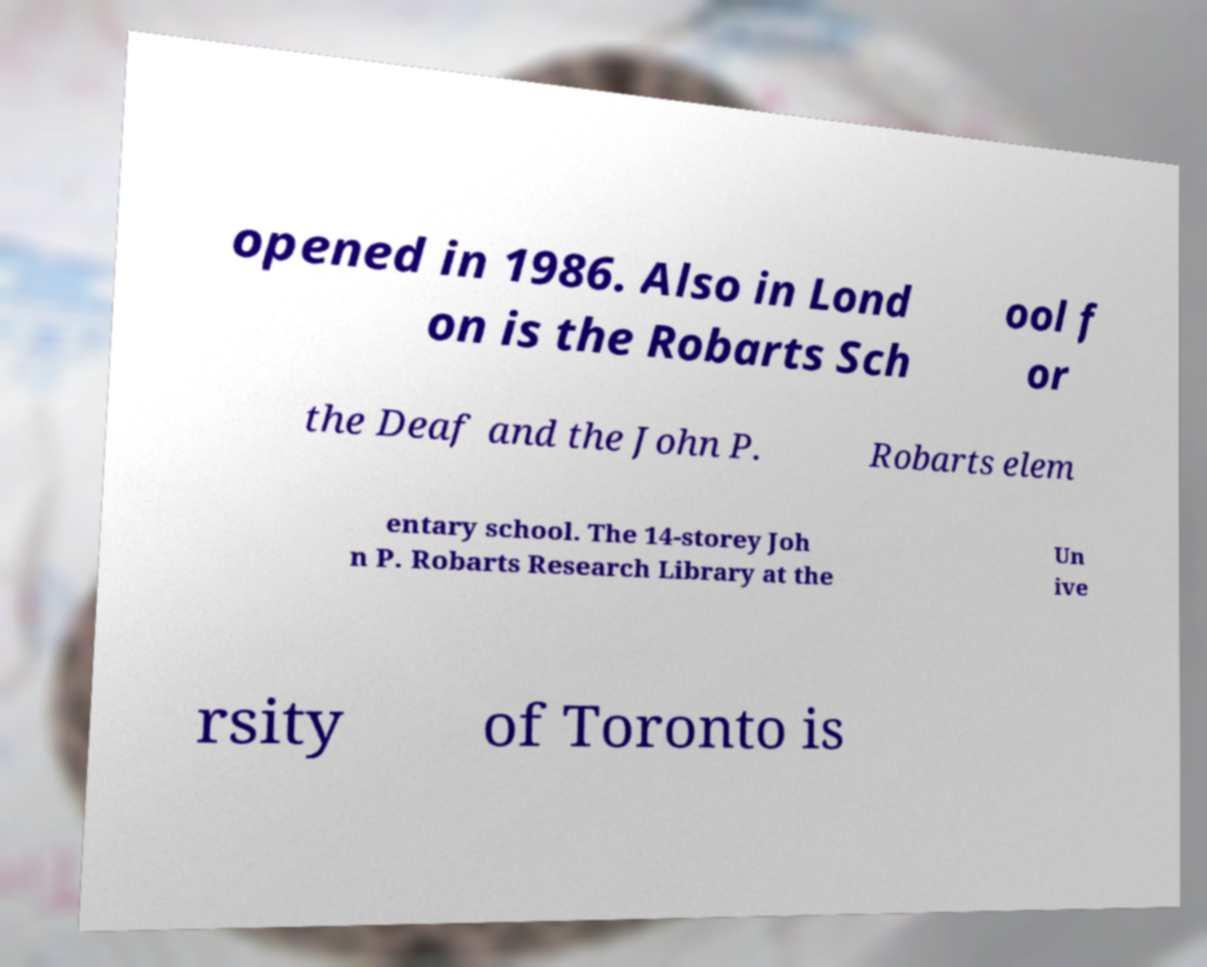There's text embedded in this image that I need extracted. Can you transcribe it verbatim? opened in 1986. Also in Lond on is the Robarts Sch ool f or the Deaf and the John P. Robarts elem entary school. The 14-storey Joh n P. Robarts Research Library at the Un ive rsity of Toronto is 